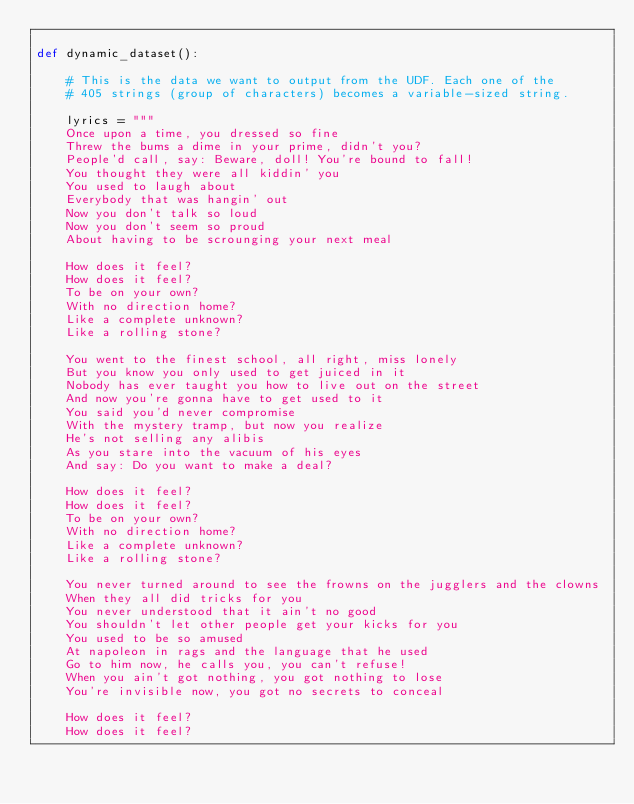<code> <loc_0><loc_0><loc_500><loc_500><_Python_>
def dynamic_dataset():

    # This is the data we want to output from the UDF. Each one of the
    # 405 strings (group of characters) becomes a variable-sized string.

    lyrics = """
    Once upon a time, you dressed so fine
    Threw the bums a dime in your prime, didn't you?
    People'd call, say: Beware, doll! You're bound to fall!
    You thought they were all kiddin' you
    You used to laugh about
    Everybody that was hangin' out
    Now you don't talk so loud
    Now you don't seem so proud
    About having to be scrounging your next meal

    How does it feel?
    How does it feel?
    To be on your own?
    With no direction home?
    Like a complete unknown?
    Like a rolling stone?

    You went to the finest school, all right, miss lonely
    But you know you only used to get juiced in it
    Nobody has ever taught you how to live out on the street
    And now you're gonna have to get used to it
    You said you'd never compromise
    With the mystery tramp, but now you realize
    He's not selling any alibis
    As you stare into the vacuum of his eyes
    And say: Do you want to make a deal?

    How does it feel?
    How does it feel?
    To be on your own?
    With no direction home?
    Like a complete unknown?
    Like a rolling stone?

    You never turned around to see the frowns on the jugglers and the clowns
    When they all did tricks for you
    You never understood that it ain't no good
    You shouldn't let other people get your kicks for you
    You used to be so amused
    At napoleon in rags and the language that he used
    Go to him now, he calls you, you can't refuse!
    When you ain't got nothing, you got nothing to lose
    You're invisible now, you got no secrets to conceal

    How does it feel?
    How does it feel?</code> 